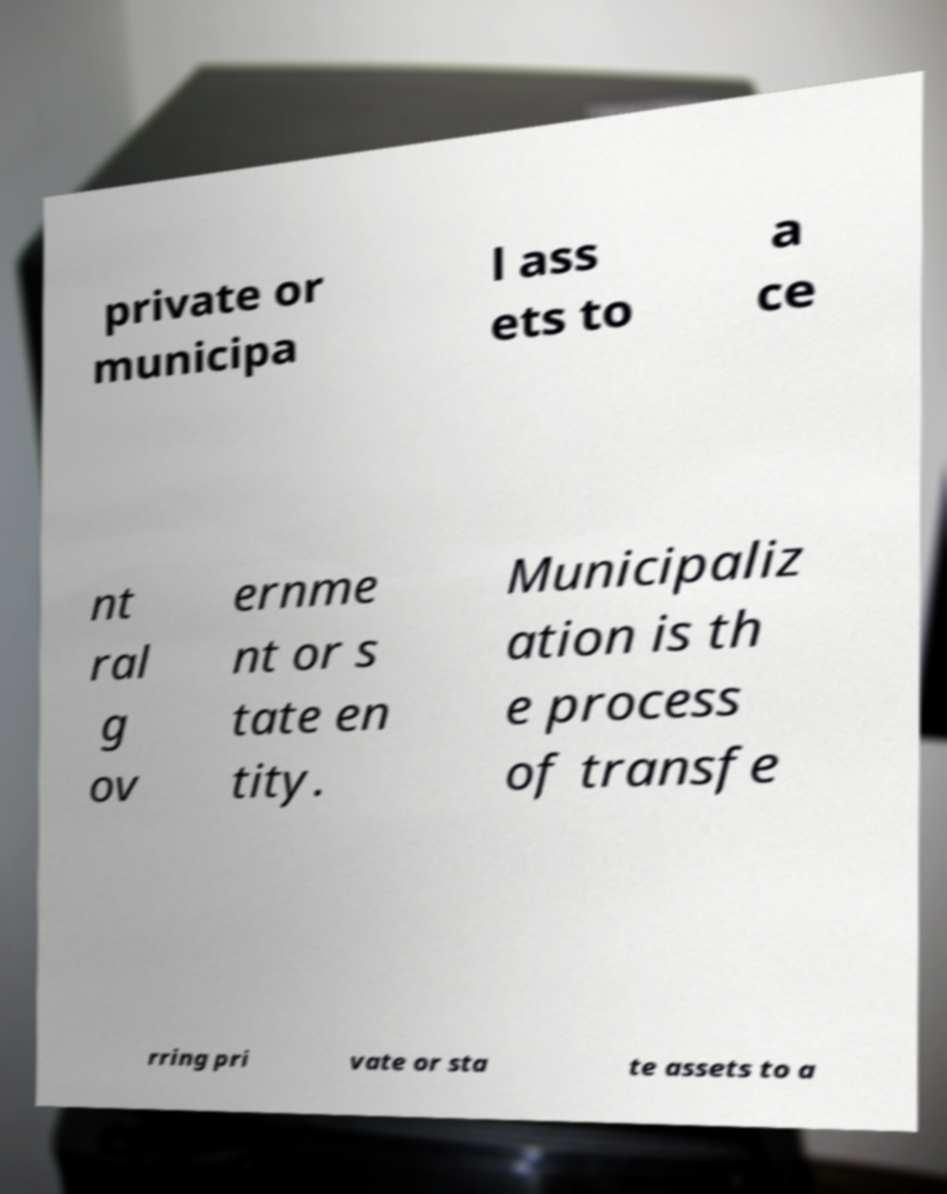For documentation purposes, I need the text within this image transcribed. Could you provide that? private or municipa l ass ets to a ce nt ral g ov ernme nt or s tate en tity. Municipaliz ation is th e process of transfe rring pri vate or sta te assets to a 